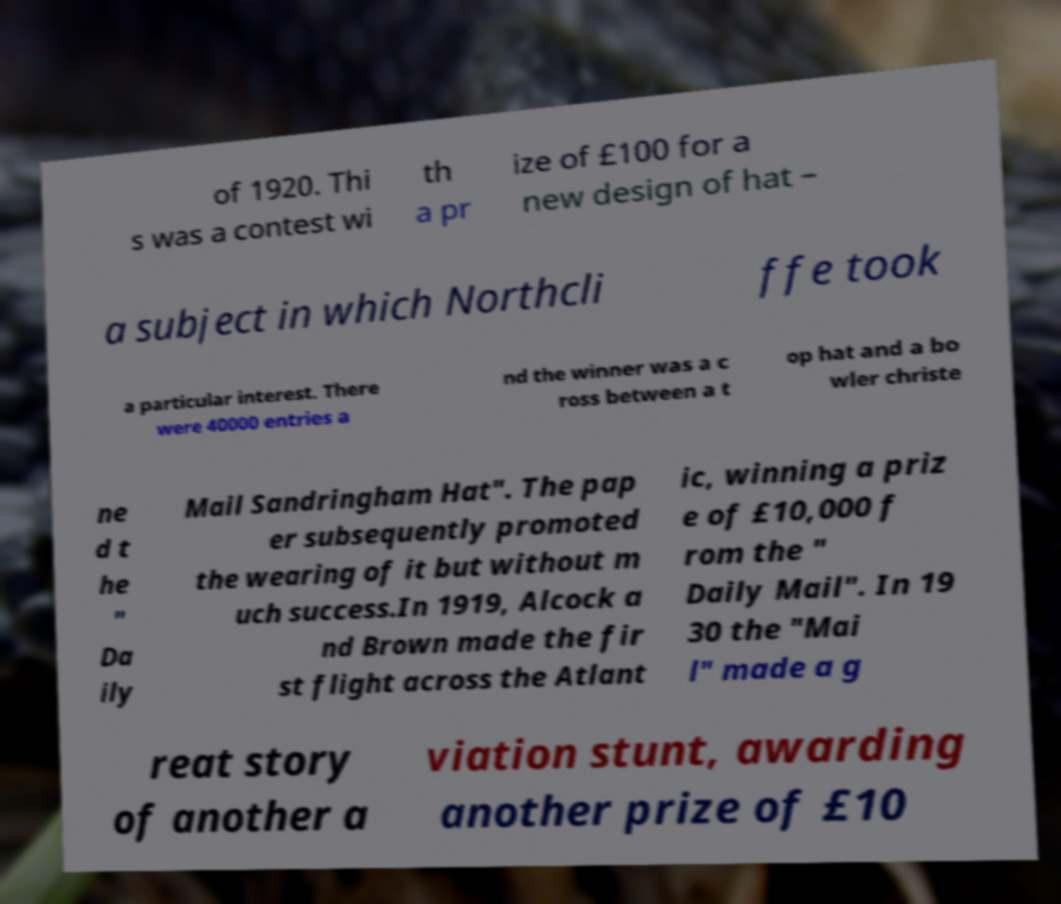Please read and relay the text visible in this image. What does it say? of 1920. Thi s was a contest wi th a pr ize of £100 for a new design of hat – a subject in which Northcli ffe took a particular interest. There were 40000 entries a nd the winner was a c ross between a t op hat and a bo wler christe ne d t he " Da ily Mail Sandringham Hat". The pap er subsequently promoted the wearing of it but without m uch success.In 1919, Alcock a nd Brown made the fir st flight across the Atlant ic, winning a priz e of £10,000 f rom the " Daily Mail". In 19 30 the "Mai l" made a g reat story of another a viation stunt, awarding another prize of £10 